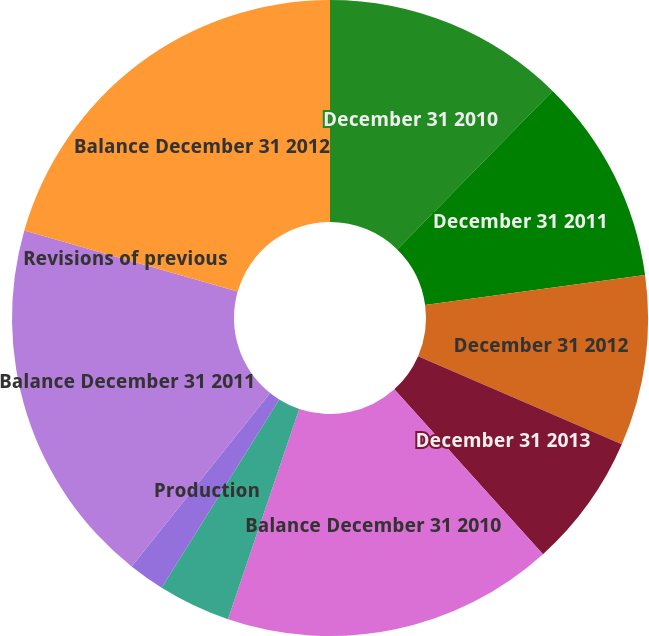Convert chart. <chart><loc_0><loc_0><loc_500><loc_500><pie_chart><fcel>December 31 2010<fcel>December 31 2011<fcel>December 31 2012<fcel>December 31 2013<fcel>Balance December 31 2010<fcel>Extensions discoveries and<fcel>Production<fcel>Balance December 31 2011<fcel>Revisions of previous<fcel>Balance December 31 2012<nl><fcel>12.34%<fcel>10.5%<fcel>8.66%<fcel>6.82%<fcel>16.88%<fcel>3.68%<fcel>1.84%<fcel>18.72%<fcel>0.0%<fcel>20.56%<nl></chart> 